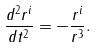Convert formula to latex. <formula><loc_0><loc_0><loc_500><loc_500>\frac { d ^ { 2 } r ^ { i } } { d t ^ { 2 } } = - \frac { r ^ { i } } { r ^ { 3 } } .</formula> 